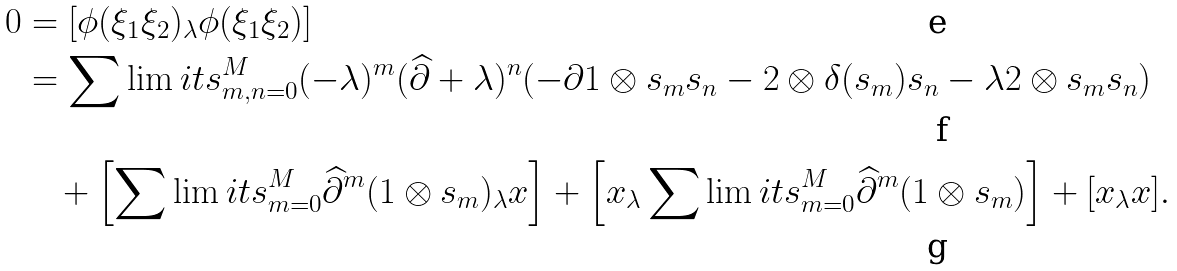<formula> <loc_0><loc_0><loc_500><loc_500>0 & = [ \phi ( \xi _ { 1 } \xi _ { 2 } ) _ { \lambda } \phi ( \xi _ { 1 } \xi _ { 2 } ) ] \\ & = \sum \lim i t s _ { m , n = 0 } ^ { M } ( - \lambda ) ^ { m } ( \widehat { \partial } + \lambda ) ^ { n } ( - \partial 1 \otimes s _ { m } s _ { n } - 2 \otimes \delta ( s _ { m } ) s _ { n } - \lambda 2 \otimes s _ { m } s _ { n } ) \\ & \quad + \left [ \sum \lim i t s _ { m = 0 } ^ { M } \widehat { \partial } ^ { m } ( 1 \otimes s _ { m } ) _ { \lambda } x \right ] + \left [ x _ { \lambda } \sum \lim i t s _ { m = 0 } ^ { M } \widehat { \partial } ^ { m } ( 1 \otimes s _ { m } ) \right ] + [ x _ { \lambda } x ] .</formula> 